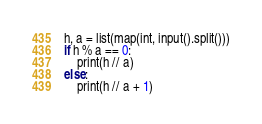<code> <loc_0><loc_0><loc_500><loc_500><_Python_>h, a = list(map(int, input().split()))
if h % a == 0:
    print(h // a)
else:
    print(h // a + 1)</code> 